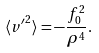Convert formula to latex. <formula><loc_0><loc_0><loc_500><loc_500>\langle { v ^ { \prime } } ^ { 2 } \rangle = - \frac { f _ { 0 } ^ { 2 } } { \rho ^ { 4 } } .</formula> 